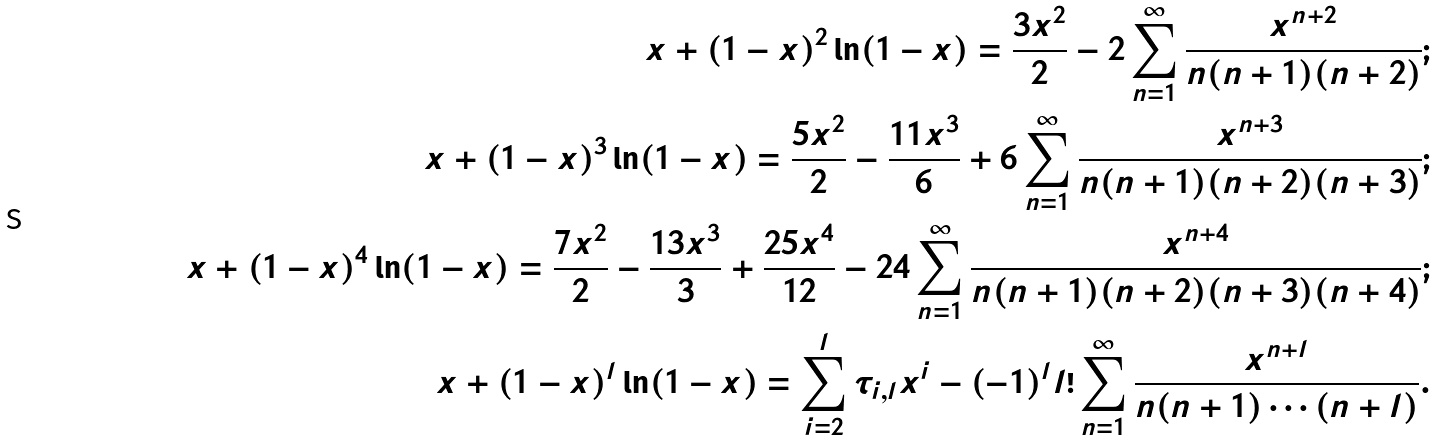<formula> <loc_0><loc_0><loc_500><loc_500>x + ( 1 - x ) ^ { 2 } \ln ( 1 - x ) = \frac { 3 x ^ { 2 } } { 2 } - 2 \sum _ { n = 1 } ^ { \infty } \frac { x ^ { n + 2 } } { n ( n + 1 ) ( n + 2 ) } ; \\ x + ( 1 - x ) ^ { 3 } \ln ( 1 - x ) = \frac { 5 x ^ { 2 } } { 2 } - \frac { 1 1 x ^ { 3 } } { 6 } + 6 \sum _ { n = 1 } ^ { \infty } \frac { x ^ { n + 3 } } { n ( n + 1 ) ( n + 2 ) ( n + 3 ) } ; \\ x + ( 1 - x ) ^ { 4 } \ln ( 1 - x ) = \frac { 7 x ^ { 2 } } { 2 } - \frac { 1 3 x ^ { 3 } } { 3 } + \frac { 2 5 x ^ { 4 } } { 1 2 } - 2 4 \sum _ { n = 1 } ^ { \infty } \frac { x ^ { n + 4 } } { n ( n + 1 ) ( n + 2 ) ( n + 3 ) ( n + 4 ) } ; \\ x + ( 1 - x ) ^ { l } \ln ( 1 - x ) = \sum _ { i = 2 } ^ { l } \tau _ { i , l } x ^ { i } - ( - 1 ) ^ { l } l ! \sum _ { n = 1 } ^ { \infty } \frac { x ^ { n + l } } { n ( n + 1 ) \cdots ( n + l ) } .</formula> 